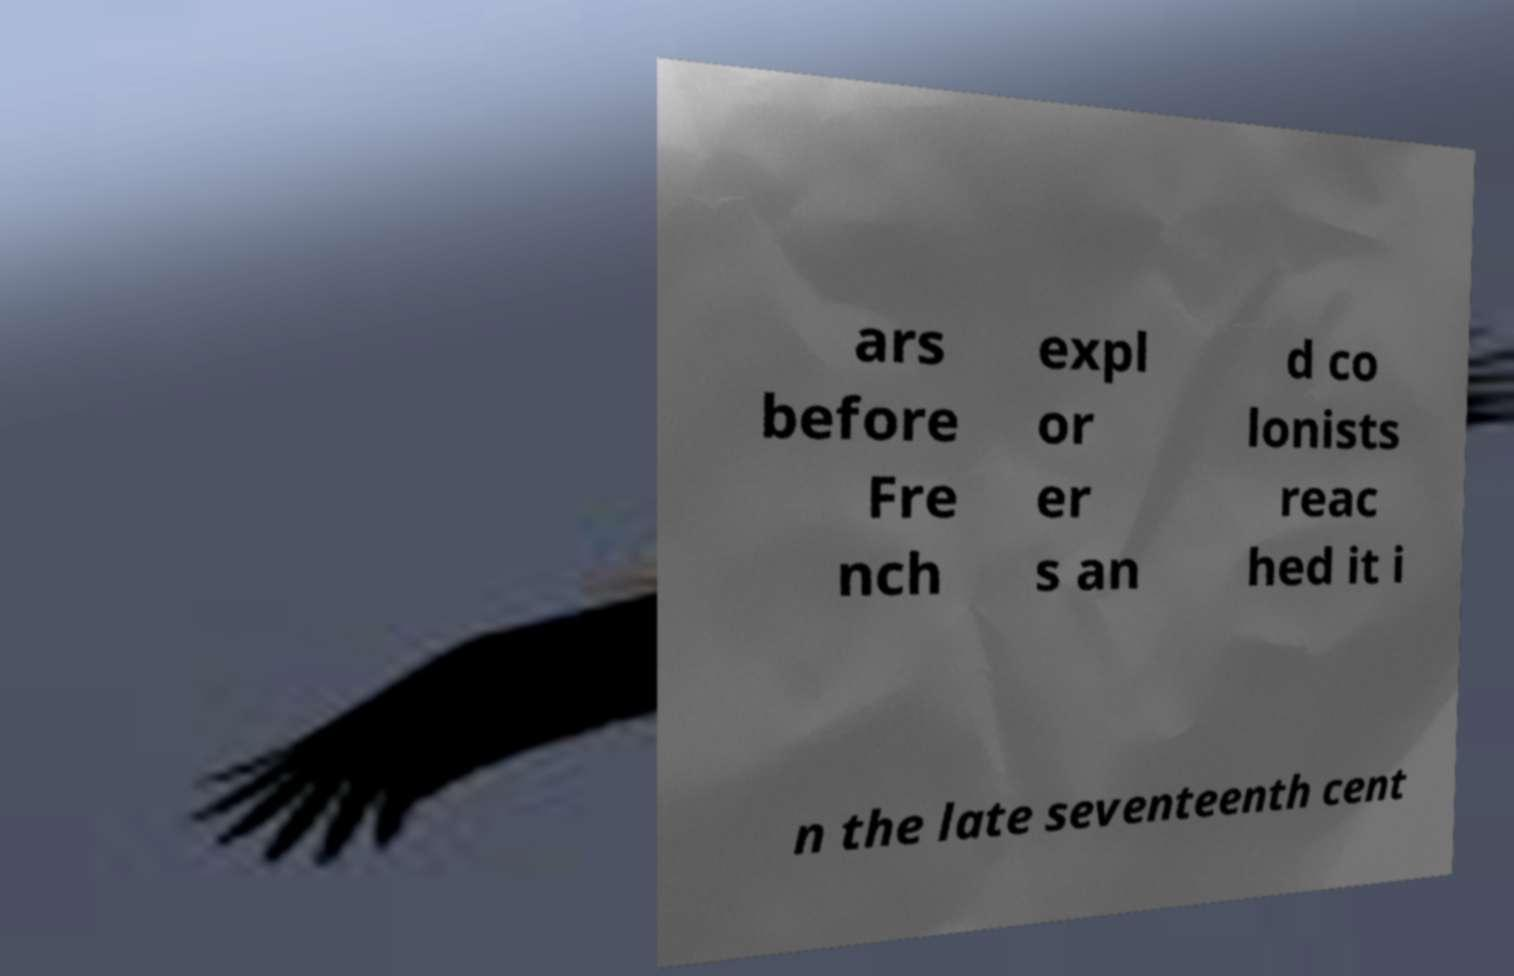Can you read and provide the text displayed in the image?This photo seems to have some interesting text. Can you extract and type it out for me? ars before Fre nch expl or er s an d co lonists reac hed it i n the late seventeenth cent 